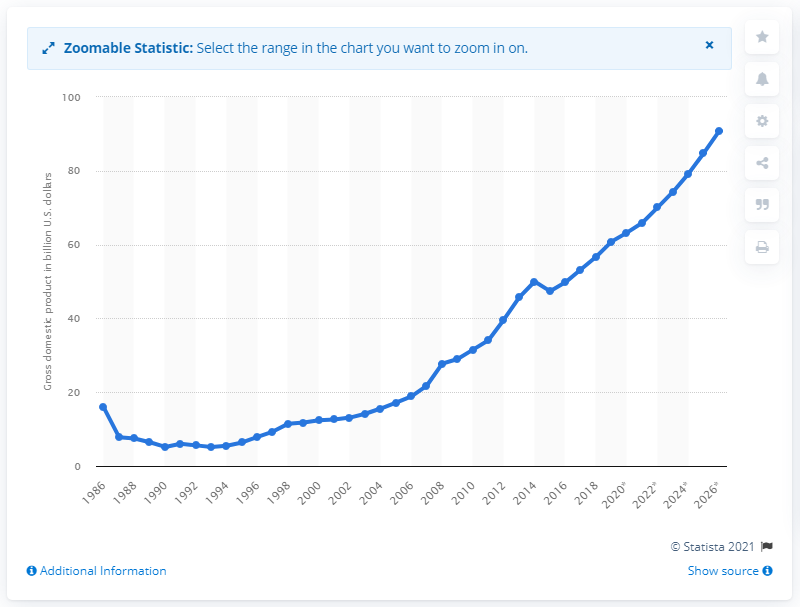Specify some key components in this picture. In 2019, Tanzania's gross domestic product (GDP) was 60.81. 